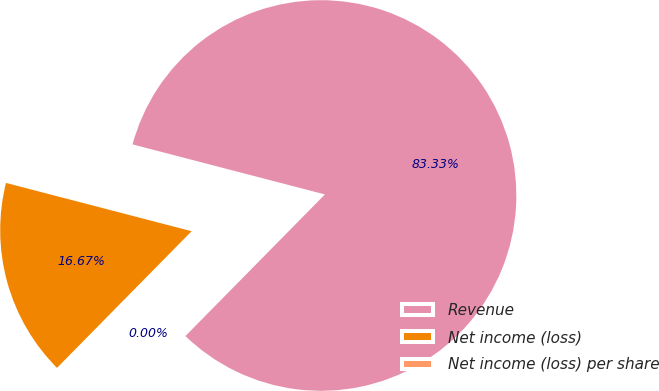<chart> <loc_0><loc_0><loc_500><loc_500><pie_chart><fcel>Revenue<fcel>Net income (loss)<fcel>Net income (loss) per share<nl><fcel>83.33%<fcel>16.67%<fcel>0.0%<nl></chart> 